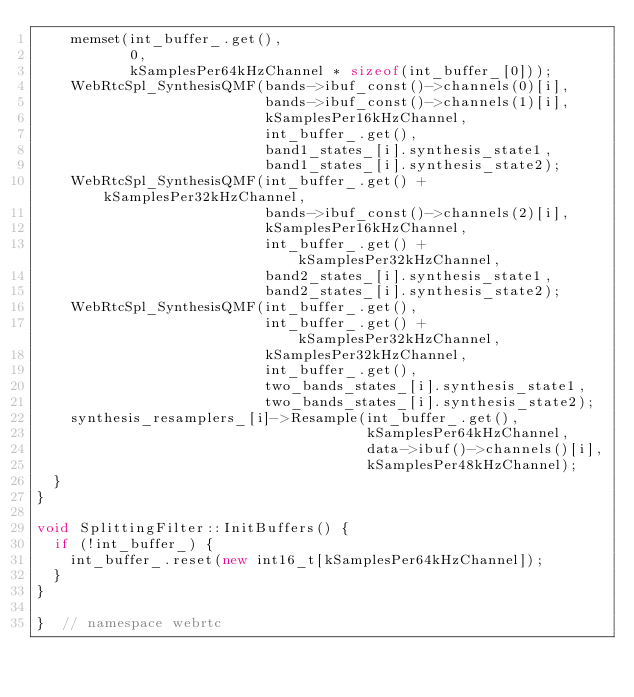<code> <loc_0><loc_0><loc_500><loc_500><_C++_>    memset(int_buffer_.get(),
           0,
           kSamplesPer64kHzChannel * sizeof(int_buffer_[0]));
    WebRtcSpl_SynthesisQMF(bands->ibuf_const()->channels(0)[i],
                           bands->ibuf_const()->channels(1)[i],
                           kSamplesPer16kHzChannel,
                           int_buffer_.get(),
                           band1_states_[i].synthesis_state1,
                           band1_states_[i].synthesis_state2);
    WebRtcSpl_SynthesisQMF(int_buffer_.get() + kSamplesPer32kHzChannel,
                           bands->ibuf_const()->channels(2)[i],
                           kSamplesPer16kHzChannel,
                           int_buffer_.get() + kSamplesPer32kHzChannel,
                           band2_states_[i].synthesis_state1,
                           band2_states_[i].synthesis_state2);
    WebRtcSpl_SynthesisQMF(int_buffer_.get(),
                           int_buffer_.get() + kSamplesPer32kHzChannel,
                           kSamplesPer32kHzChannel,
                           int_buffer_.get(),
                           two_bands_states_[i].synthesis_state1,
                           two_bands_states_[i].synthesis_state2);
    synthesis_resamplers_[i]->Resample(int_buffer_.get(),
                                       kSamplesPer64kHzChannel,
                                       data->ibuf()->channels()[i],
                                       kSamplesPer48kHzChannel);
  }
}

void SplittingFilter::InitBuffers() {
  if (!int_buffer_) {
    int_buffer_.reset(new int16_t[kSamplesPer64kHzChannel]);
  }
}

}  // namespace webrtc
</code> 